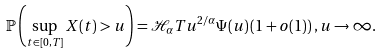<formula> <loc_0><loc_0><loc_500><loc_500>\mathbb { P } \left ( \sup _ { t \in [ 0 , T ] } X ( t ) > u \right ) = \mathcal { H } _ { \alpha } T u ^ { { 2 } / { \alpha } } \Psi ( u ) \left ( 1 + o ( 1 ) \right ) , u \rightarrow \infty .</formula> 